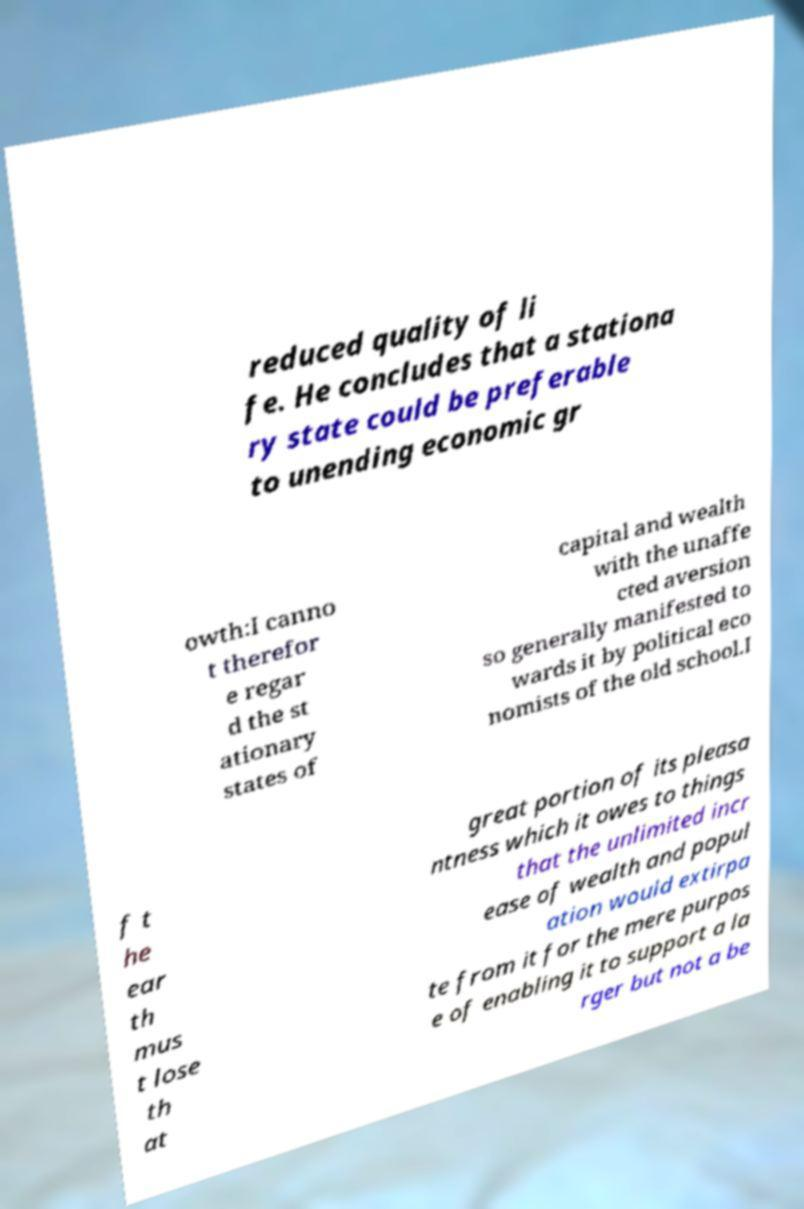I need the written content from this picture converted into text. Can you do that? reduced quality of li fe. He concludes that a stationa ry state could be preferable to unending economic gr owth:I canno t therefor e regar d the st ationary states of capital and wealth with the unaffe cted aversion so generally manifested to wards it by political eco nomists of the old school.I f t he ear th mus t lose th at great portion of its pleasa ntness which it owes to things that the unlimited incr ease of wealth and popul ation would extirpa te from it for the mere purpos e of enabling it to support a la rger but not a be 